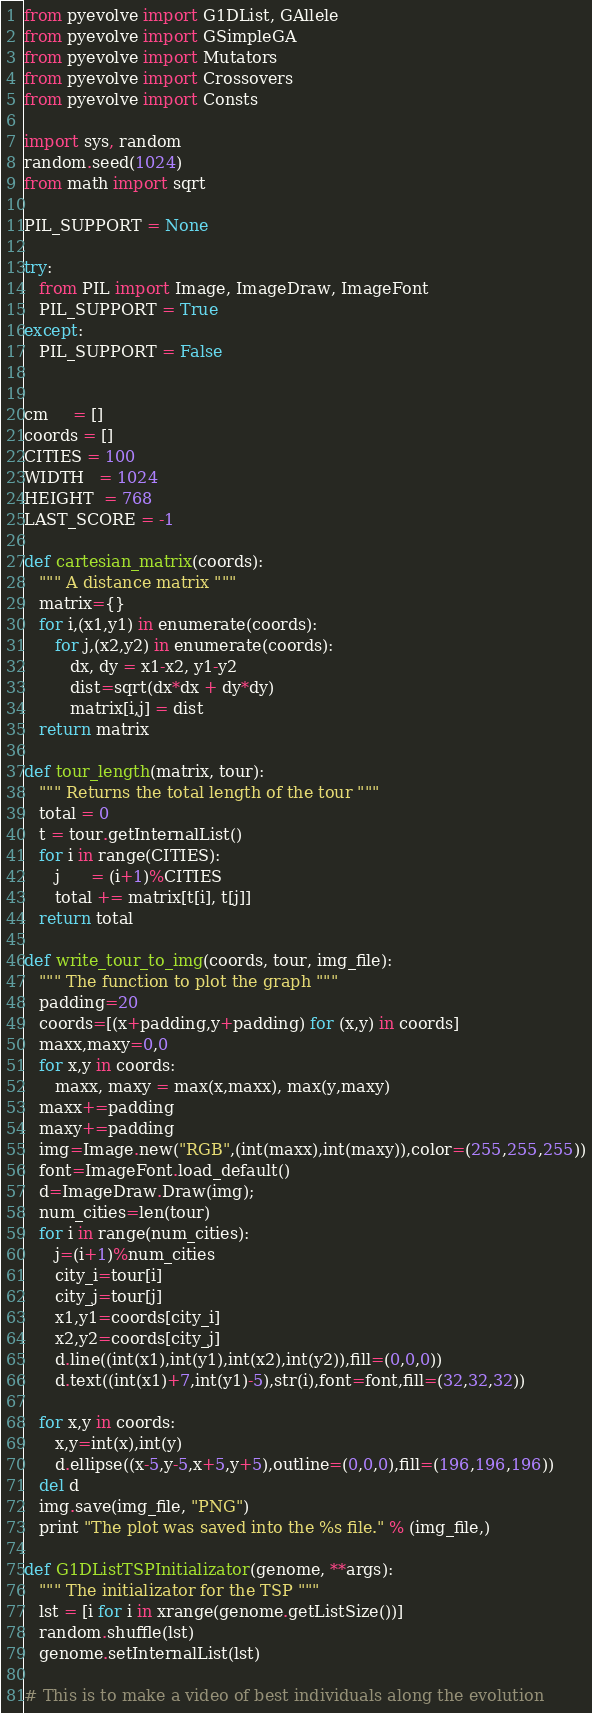<code> <loc_0><loc_0><loc_500><loc_500><_Python_>from pyevolve import G1DList, GAllele
from pyevolve import GSimpleGA
from pyevolve import Mutators
from pyevolve import Crossovers
from pyevolve import Consts

import sys, random
random.seed(1024)
from math import sqrt

PIL_SUPPORT = None

try:
   from PIL import Image, ImageDraw, ImageFont
   PIL_SUPPORT = True
except:
   PIL_SUPPORT = False


cm     = []
coords = []
CITIES = 100
WIDTH   = 1024
HEIGHT  = 768
LAST_SCORE = -1

def cartesian_matrix(coords):
   """ A distance matrix """
   matrix={}
   for i,(x1,y1) in enumerate(coords):
      for j,(x2,y2) in enumerate(coords):
         dx, dy = x1-x2, y1-y2
         dist=sqrt(dx*dx + dy*dy)
         matrix[i,j] = dist
   return matrix

def tour_length(matrix, tour):
   """ Returns the total length of the tour """
   total = 0
   t = tour.getInternalList()
   for i in range(CITIES):
      j      = (i+1)%CITIES
      total += matrix[t[i], t[j]]
   return total

def write_tour_to_img(coords, tour, img_file):
   """ The function to plot the graph """
   padding=20
   coords=[(x+padding,y+padding) for (x,y) in coords]
   maxx,maxy=0,0
   for x,y in coords:
      maxx, maxy = max(x,maxx), max(y,maxy)
   maxx+=padding
   maxy+=padding
   img=Image.new("RGB",(int(maxx),int(maxy)),color=(255,255,255))
   font=ImageFont.load_default()
   d=ImageDraw.Draw(img);
   num_cities=len(tour)
   for i in range(num_cities):
      j=(i+1)%num_cities
      city_i=tour[i]
      city_j=tour[j]
      x1,y1=coords[city_i]
      x2,y2=coords[city_j]
      d.line((int(x1),int(y1),int(x2),int(y2)),fill=(0,0,0))
      d.text((int(x1)+7,int(y1)-5),str(i),font=font,fill=(32,32,32))

   for x,y in coords:
      x,y=int(x),int(y)
      d.ellipse((x-5,y-5,x+5,y+5),outline=(0,0,0),fill=(196,196,196))
   del d
   img.save(img_file, "PNG")
   print "The plot was saved into the %s file." % (img_file,)

def G1DListTSPInitializator(genome, **args):
   """ The initializator for the TSP """
   lst = [i for i in xrange(genome.getListSize())]
   random.shuffle(lst)
   genome.setInternalList(lst)

# This is to make a video of best individuals along the evolution</code> 